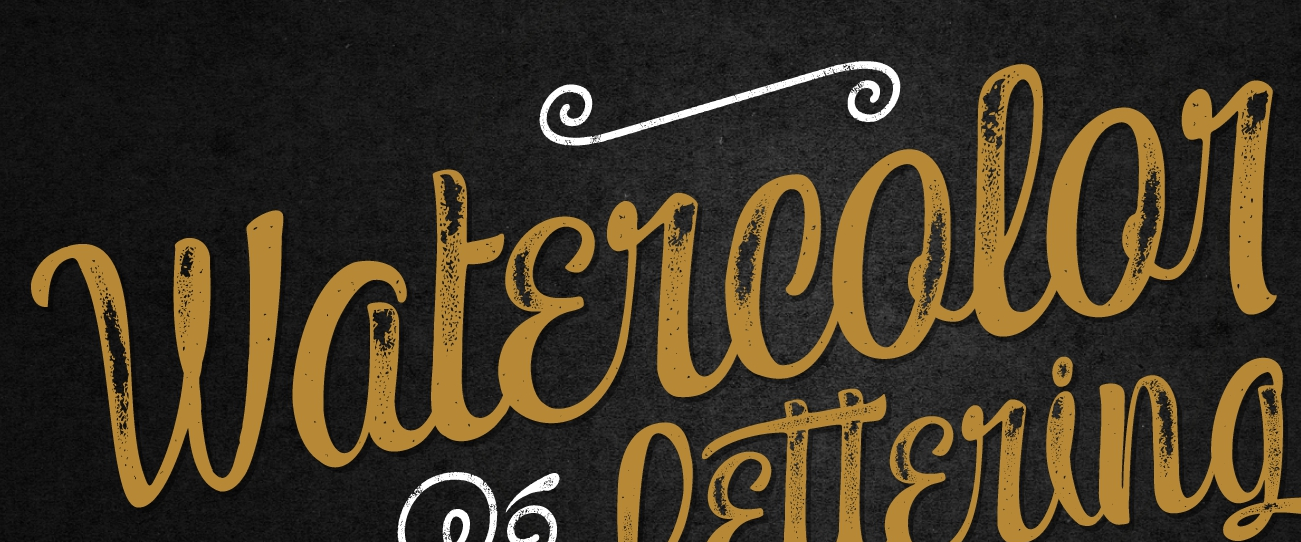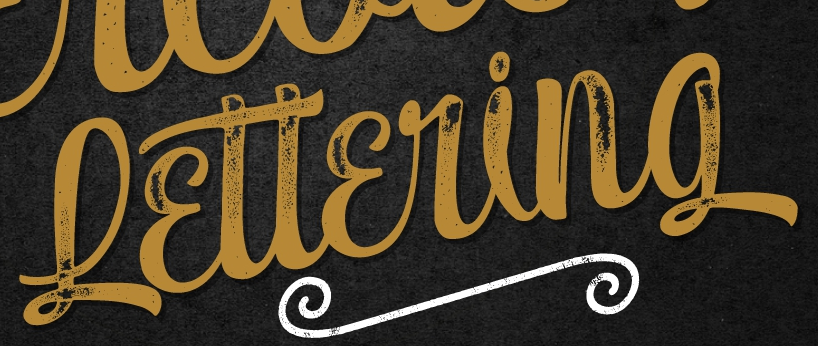What words can you see in these images in sequence, separated by a semicolon? Watɛrcolor; Lɛttɛring 